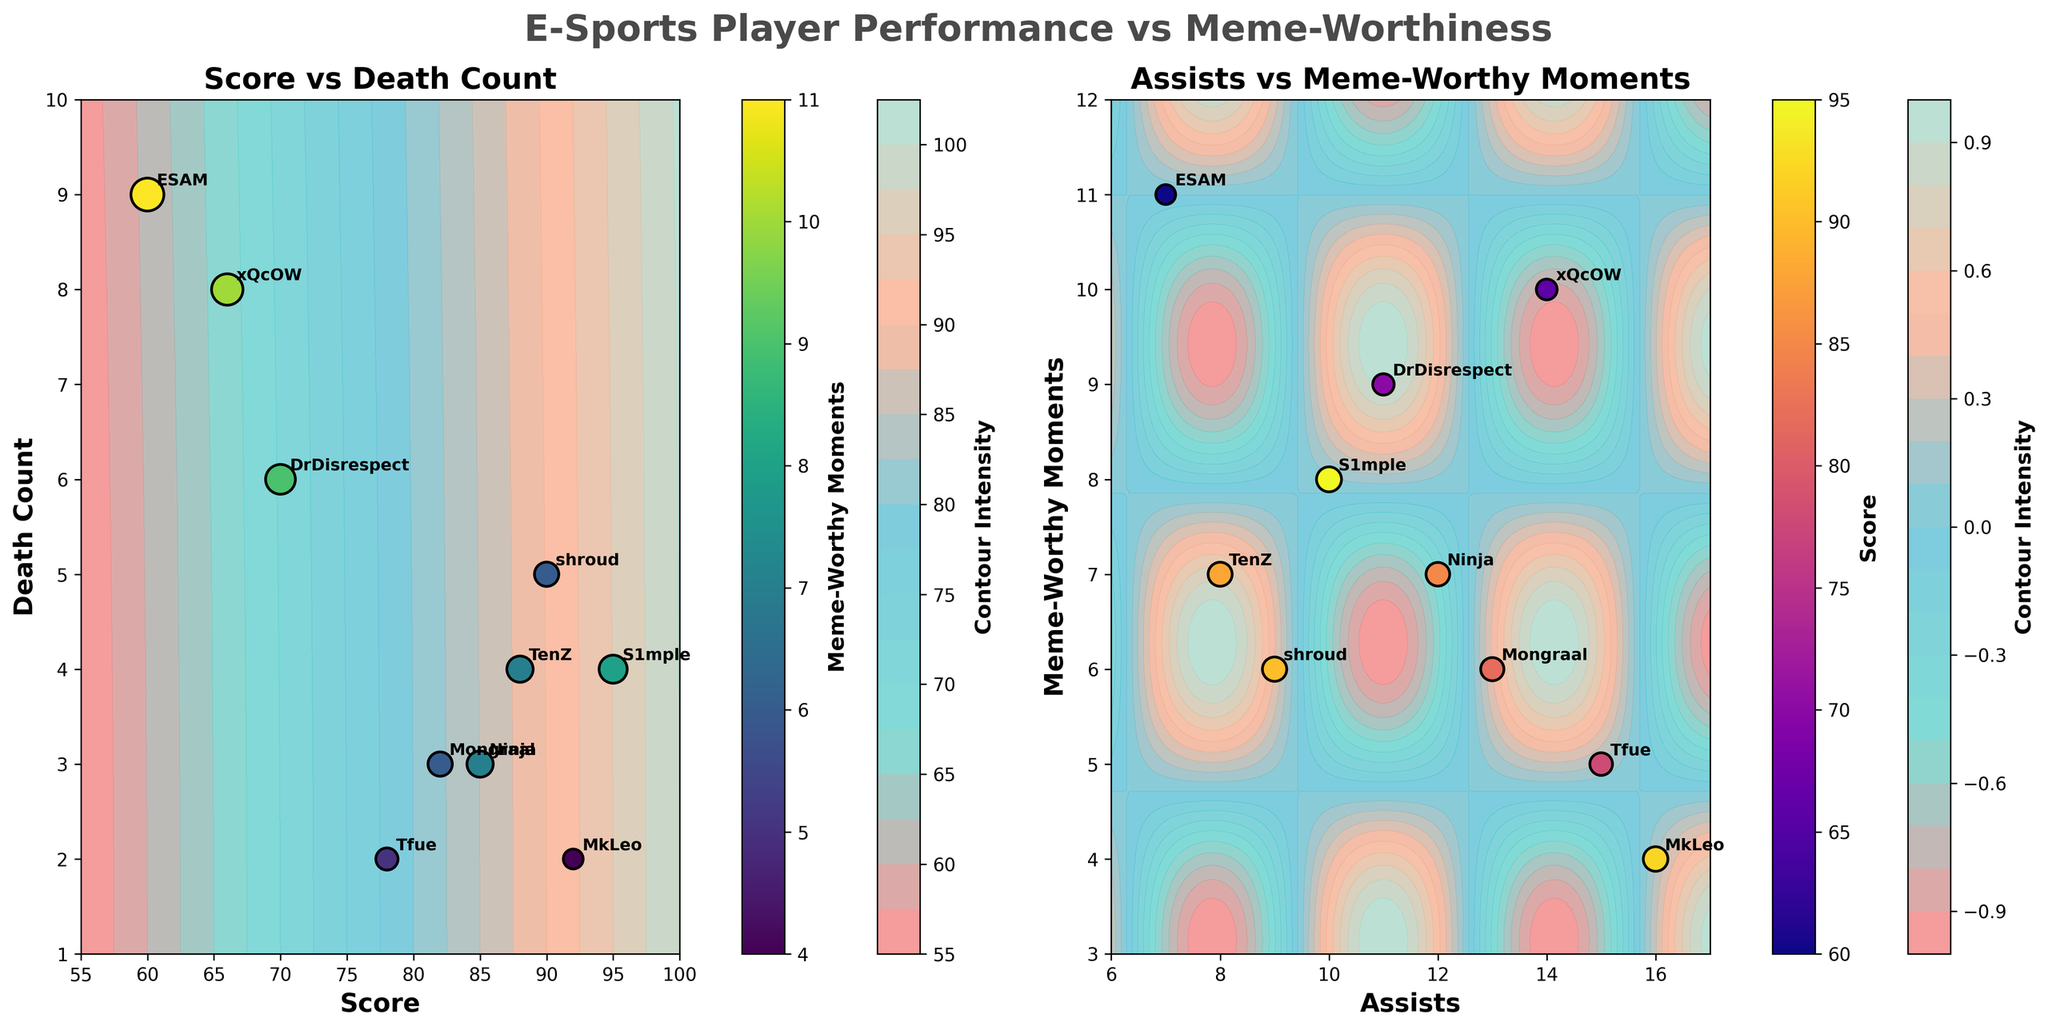What is the title of the figure? The title is usually found at the top of the figure. In this case, it reads "E-Sports Player Performance vs Meme-Worthiness".
Answer: E-Sports Player Performance vs Meme-Worthiness How many subplots are in the figure? By visually inspecting the layout of the figure, we can count that there are two separate plots displayed side-by-side.
Answer: Two What are the axes labels in the first subplot? The first subplot's labels can be found by looking at the text next to the horizontal and vertical axes. They read "Score" and "Death Count".
Answer: Score and Death Count Which player has the highest Death Count in the first subplot? By examining the "Death Count" axis and the annotated names, the player "ESAM" appears at the highest position on the y-axis.
Answer: ESAM On the second subplot, which player has the highest number of Assists? By looking at the "Assists" axis and identifying player names at the highest position, "MkLeo" has the highest number of Assists.
Answer: MkLeo Which player is represented with the largest size marker in the second subplot? Marker size is proportional to the "Score" in the second subplot. "S1mple," with a Score of 95, has the largest marker.
Answer: S1mple Are Meme-Worthy Moments generally higher with more Death Count in the first subplot? By observing the scatter plot in the first subplot, data points with higher Death Counts tend to have brightly colored markers. This indicates more Meme-Worthy Moments.
Answer: Yes Compare the Meme-Worthy Moments between "xQcOW" and "DrDisrespect" in the first subplot. Who has more? Looking at both players' markers within the scatter plot, "xQcOW" has a value of 10 whereas "DrDisrespect" has a value of 9 for Meme-Worthy Moments.
Answer: xQcOW In the second subplot, what is the relationship between Assists and Meme-Worthy Moments? Observing the scatter plot and contour lines, there seems to be no clear linear relationship, as birders vary and attenuate without obvious correlation.
Answer: No clear correlation Which colorbar is associated with Meme-Worthy Moments in the first subplot? By inspecting next to the first subplot's scatter plot, the colorbar located to the right labeled "Meme-Worthy Moments" relates to Meme-Worthy Moments.
Answer: Right colorbar 